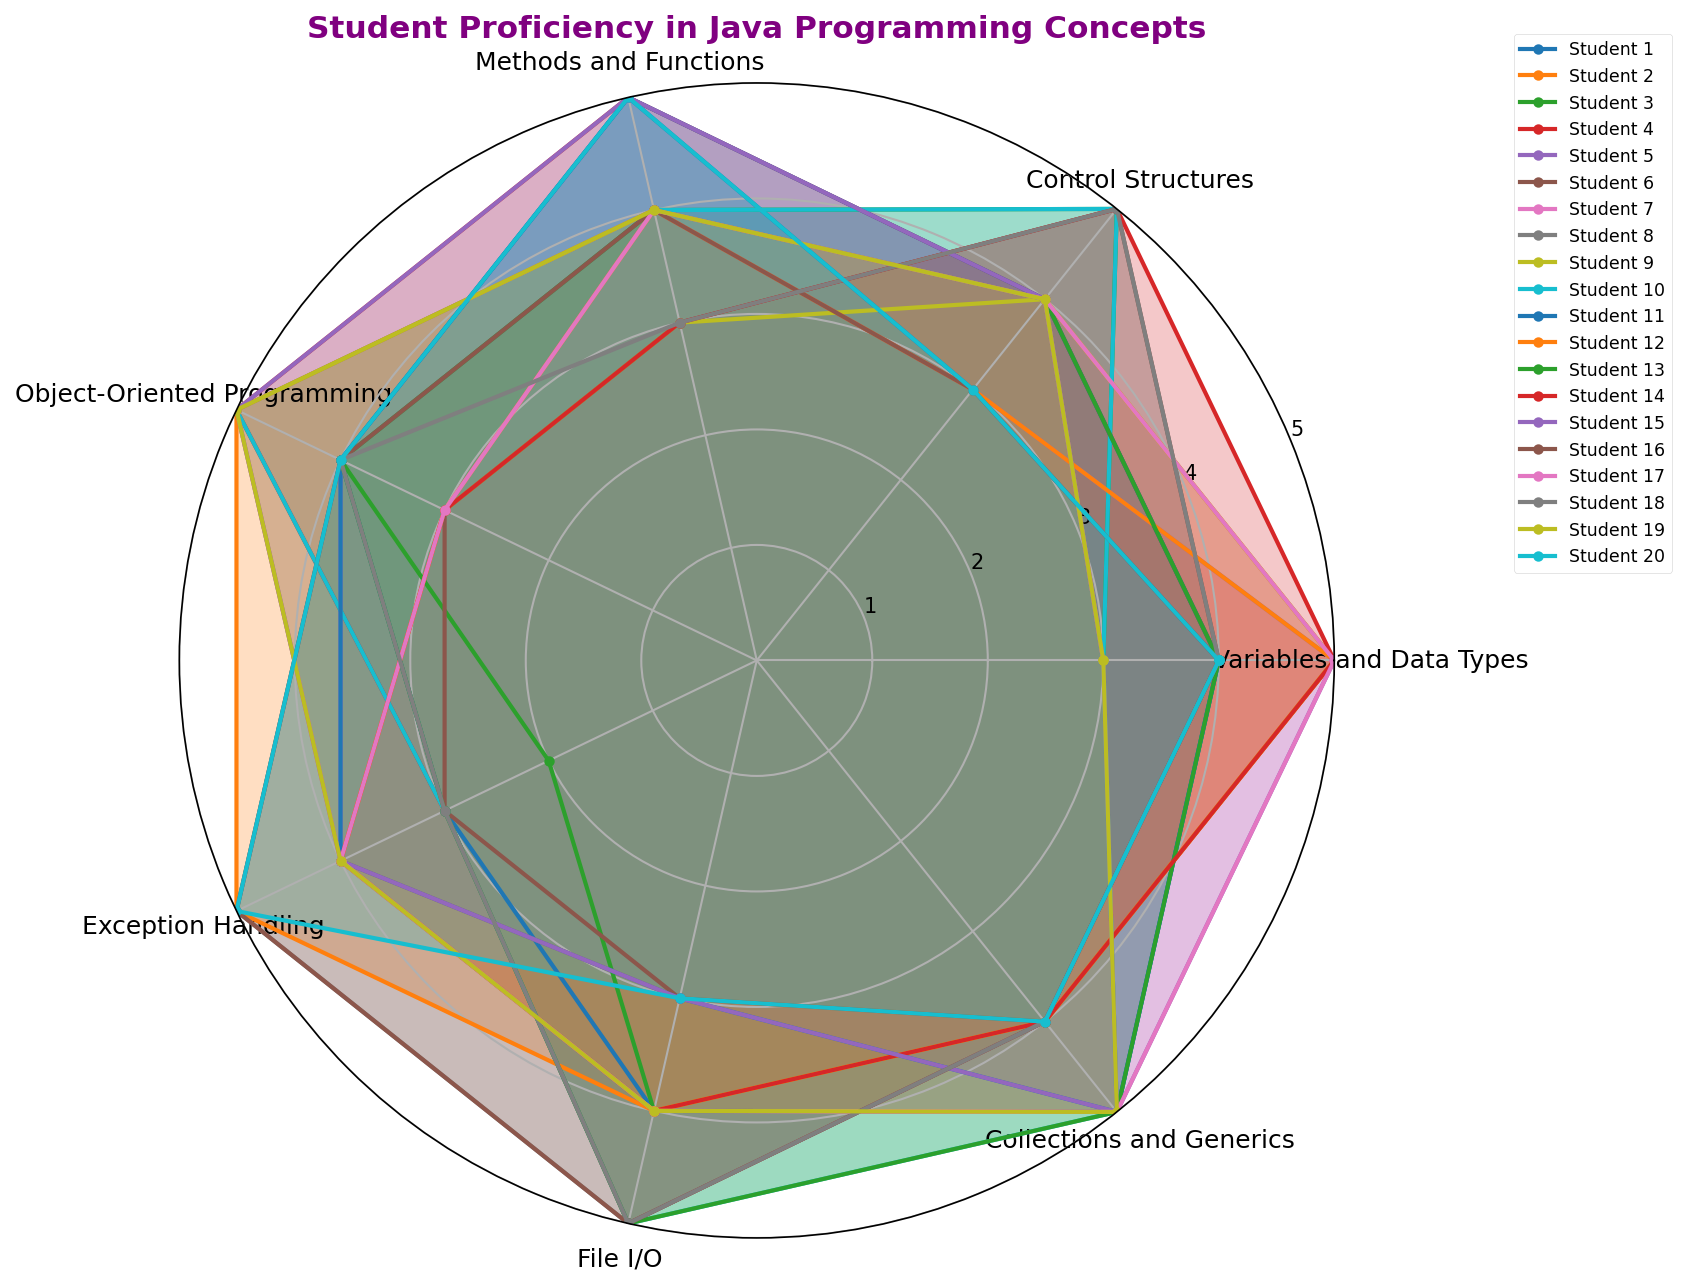Which student has the highest proficiency in Object-Oriented Programming (OOP)? Compare the proficiency levels in Object-Oriented Programming across all students. The radar chart shows that multiple students (Student 4, Student 10, Student 15, and Student 20) have the highest rating of 5 in Object-Oriented Programming.
Answer: Student 4, Student 10, Student 15, Student 20 Which student has the lowest proficiency in Exception Handling? Compare the proficiency levels in Exception Handling across all students. The radar chart shows that Student 3 and Student 18 have the lowest rating of 2.
Answer: Student 3, Student 18 What's the average proficiency level in Methods and Functions for the class? To find the average, sum the proficiency levels of Methods and Functions for all students and then divide by the number of students. Sum = 5+4+4+5+4+3+4+4+3+4+5+4+4+3+5+4+4+3+4+5 = 83; Number of students = 20; Average = 83 / 20 = 4.15
Answer: 4.15 Which student shows the most balanced proficiency across all Java programming concepts? Check for the student whose radar chart shows the least variance in the values across all the axes. A visually balanced chart would depict fairly equal distances from the center in all categories. According to the chart, Student 8 and Student 3 show a balanced proficiency across categories.
Answer: Student 8, Student 3 Which student has the highest combined proficiency in Control Structures and Collections and Generics? Sum the proficiency levels in Control Structures and Collections and Generics for each student and find the highest sum. The sums are: Student 1: 3+5=8, Student 2: 4+4=8, ..., Student 20: 3+4=7. The student with the highest sum is Student 15 with 9.
Answer: Student 15 Who scored the highest in File I/O and how does it compare to their Exception Handling score? Identify the student with the highest proficiency in File I/O and then compare their File I/O and Exception Handling scores. Student 8, Student 10, Student 13, Student 16, and Student 18 all have the highest rating of 5 in File I/O. Comparing their Exception Handling scores, we find that only Student 8 and Student 16 differ here (5 vs. 5 and 3 respectively), while others have 3 or 4.
Answer: 5 vs. 3 What is the range of proficiency levels in Variables and Data Types for the class? Find the minimum and maximum values for Variables and Data Types and calculate the range. Minimum = 3 (Student 3, 7, 10, 15, 19), Maximum = 5 (multiple students); Range = 5 - 3 = 2
Answer: 2 